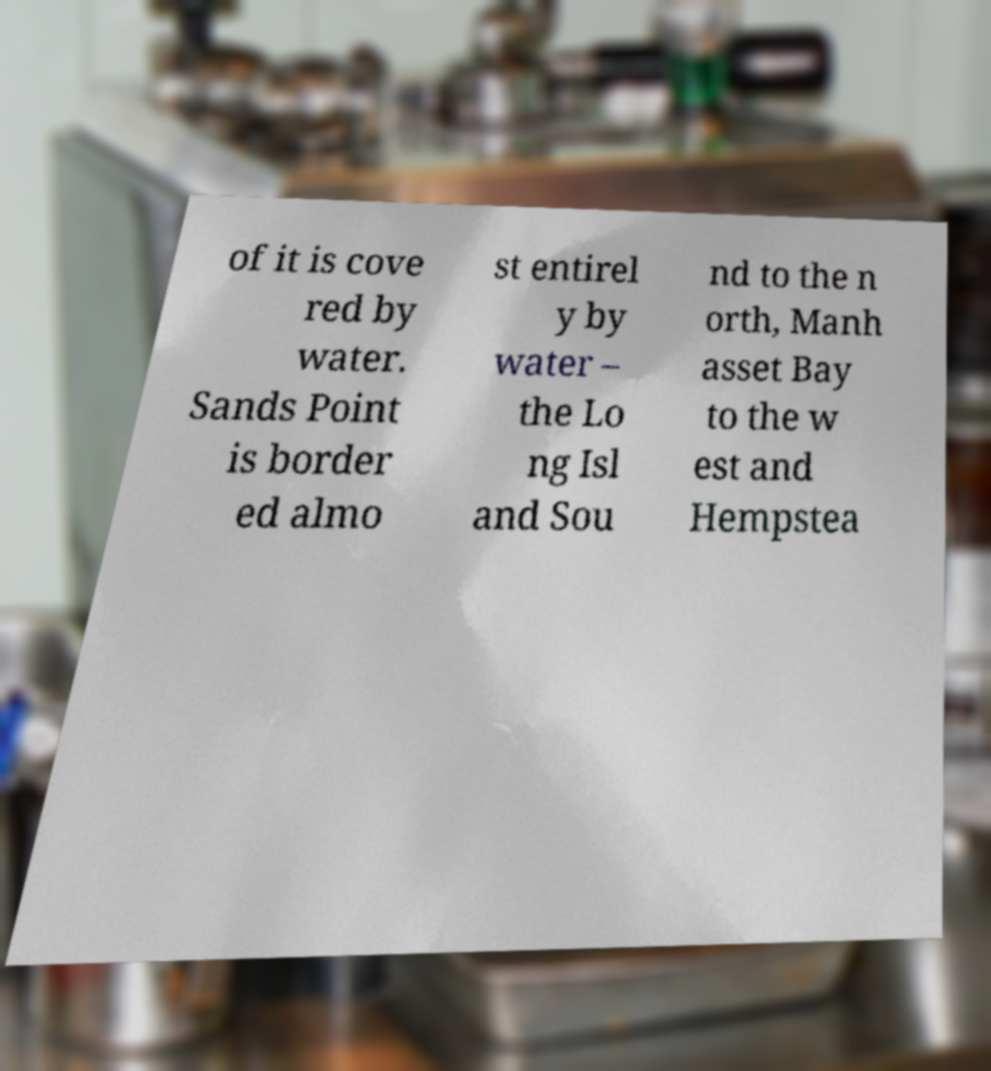Could you extract and type out the text from this image? of it is cove red by water. Sands Point is border ed almo st entirel y by water – the Lo ng Isl and Sou nd to the n orth, Manh asset Bay to the w est and Hempstea 